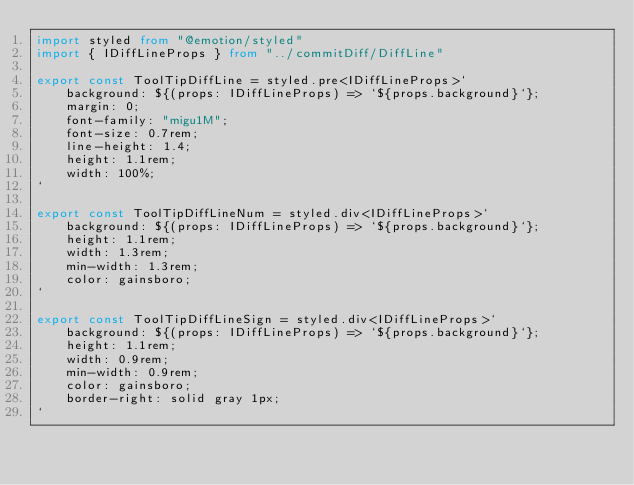<code> <loc_0><loc_0><loc_500><loc_500><_TypeScript_>import styled from "@emotion/styled"
import { IDiffLineProps } from "../commitDiff/DiffLine"

export const ToolTipDiffLine = styled.pre<IDiffLineProps>`
    background: ${(props: IDiffLineProps) => `${props.background}`};
    margin: 0;
    font-family: "migu1M";
    font-size: 0.7rem;
    line-height: 1.4;
    height: 1.1rem;
    width: 100%;
`

export const ToolTipDiffLineNum = styled.div<IDiffLineProps>`
    background: ${(props: IDiffLineProps) => `${props.background}`};
    height: 1.1rem;
    width: 1.3rem;
    min-width: 1.3rem;
    color: gainsboro;
`

export const ToolTipDiffLineSign = styled.div<IDiffLineProps>`
    background: ${(props: IDiffLineProps) => `${props.background}`};
    height: 1.1rem;
    width: 0.9rem;
    min-width: 0.9rem;
    color: gainsboro;
    border-right: solid gray 1px;
`
</code> 